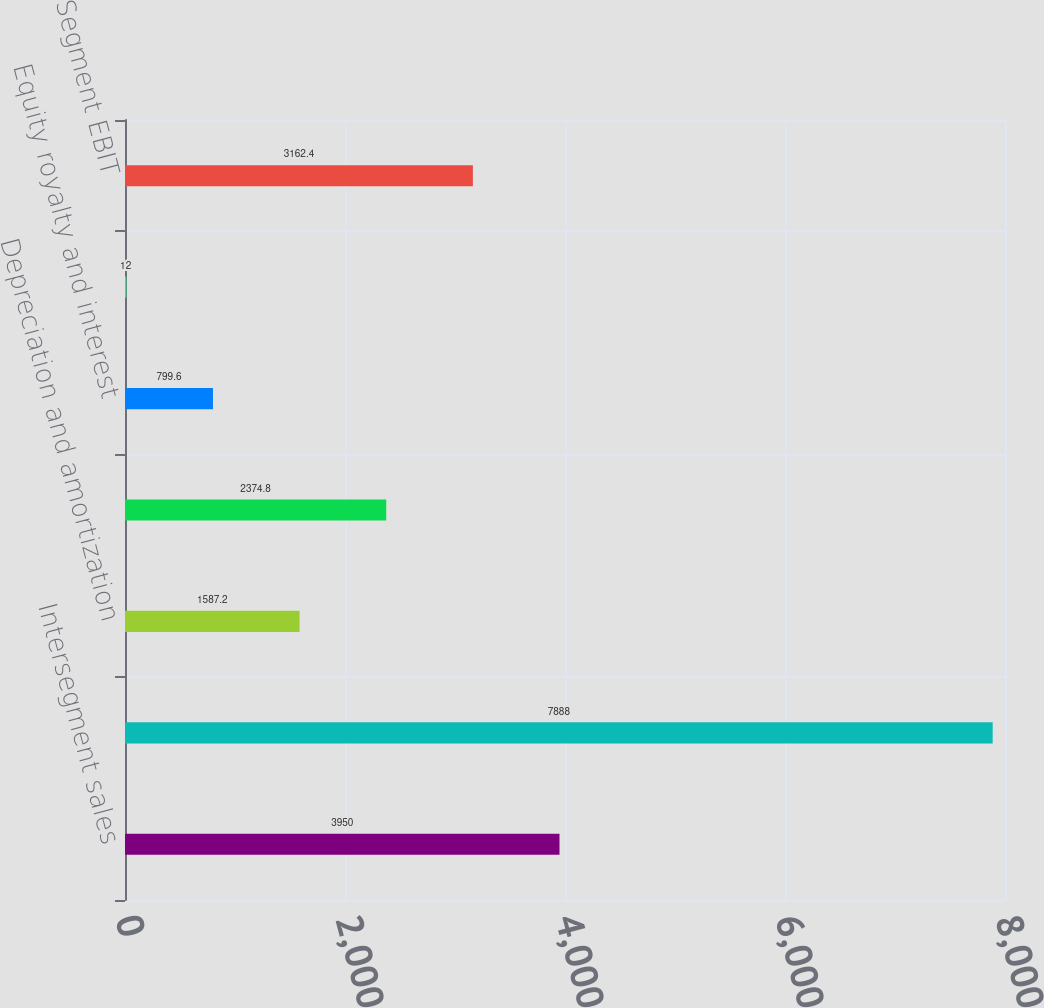Convert chart. <chart><loc_0><loc_0><loc_500><loc_500><bar_chart><fcel>Intersegment sales<fcel>Total sales<fcel>Depreciation and amortization<fcel>Research development and<fcel>Equity royalty and interest<fcel>Interest income<fcel>Segment EBIT<nl><fcel>3950<fcel>7888<fcel>1587.2<fcel>2374.8<fcel>799.6<fcel>12<fcel>3162.4<nl></chart> 